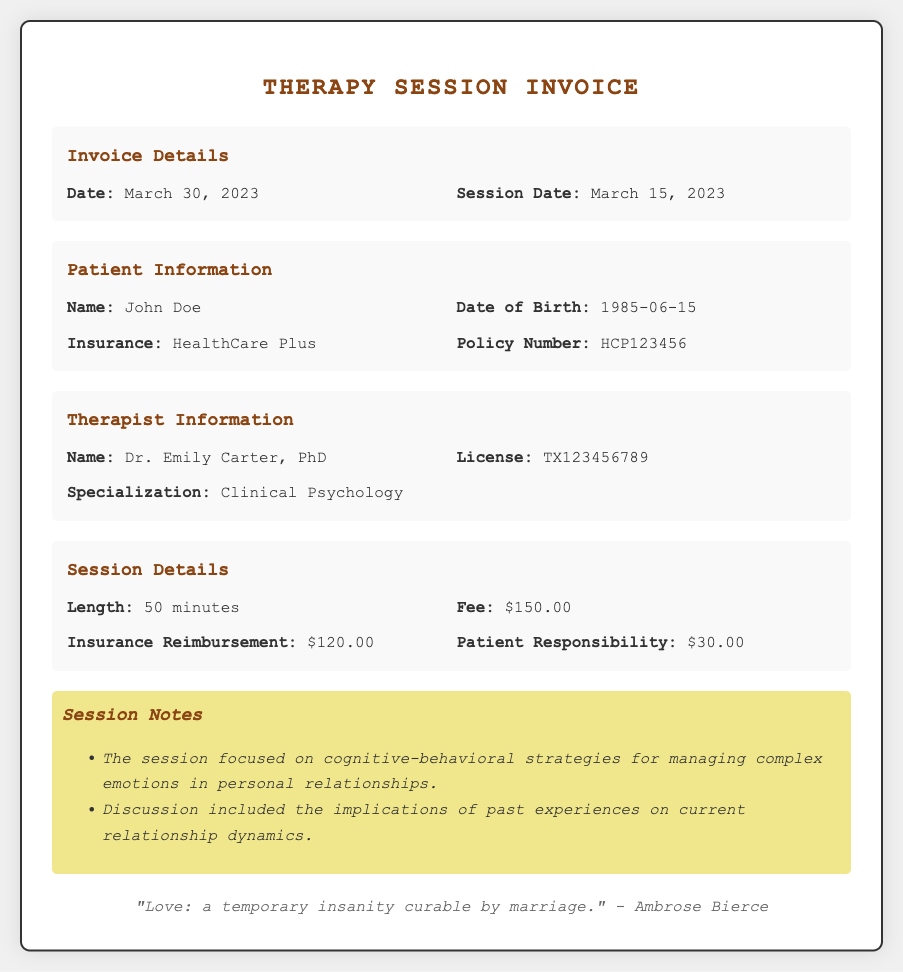What is the session date? The session date is explicitly stated in the document under the Invoice Details section.
Answer: March 15, 2023 Who is the therapist? The therapist's name is provided in the Therapist Information section.
Answer: Dr. Emily Carter, PhD What is the fee for the session? The fee is indicated in the Session Details section of the document.
Answer: $150.00 How long was the therapy session? The session length is mentioned in the Session Details section.
Answer: 50 minutes What is the patient responsibility amount? This amount is specified in the Session Details section.
Answer: $30.00 What was discussed in the session? The session notes detail the focus of the session about relationships and personal experiences.
Answer: Cognitive-behavioral strategies for managing complex emotions in personal relationships What insurance does the patient have? The insurance information is provided in the Patient Information section.
Answer: HealthCare Plus What was the insurance reimbursement amount? The reimbursement amount is listed in the Session Details section.
Answer: $120.00 What is the policy number for the insurance? The policy number is clearly noted in the Patient Information section.
Answer: HCP123456 